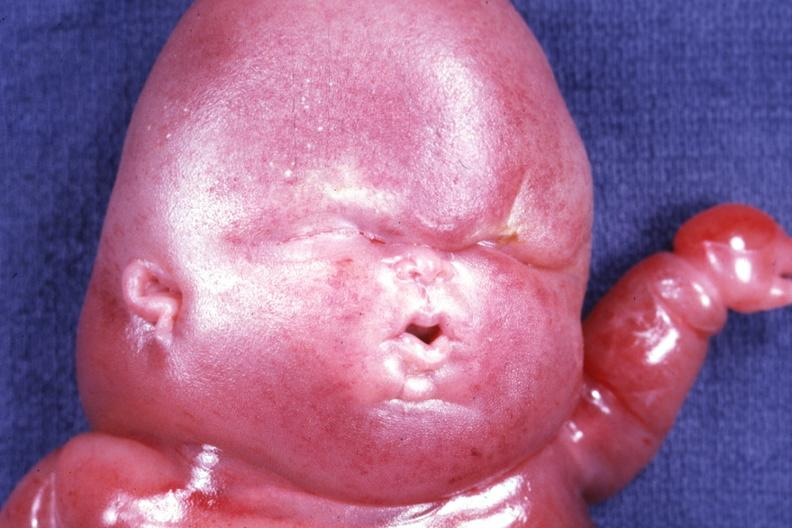s lymphangiomatosis present?
Answer the question using a single word or phrase. Yes 